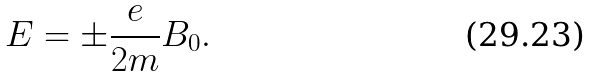Convert formula to latex. <formula><loc_0><loc_0><loc_500><loc_500>E = \pm \frac { e } { 2 m } B _ { 0 } .</formula> 